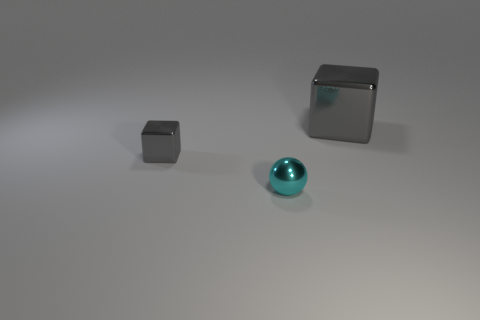Add 3 cyan balls. How many objects exist? 6 Subtract all spheres. How many objects are left? 2 Subtract all metal balls. Subtract all tiny metallic spheres. How many objects are left? 1 Add 3 cyan metal things. How many cyan metal things are left? 4 Add 2 tiny gray metal things. How many tiny gray metal things exist? 3 Subtract 0 red balls. How many objects are left? 3 Subtract all green spheres. Subtract all gray blocks. How many spheres are left? 1 